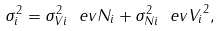<formula> <loc_0><loc_0><loc_500><loc_500>\sigma ^ { 2 } _ { i } = \sigma ^ { 2 } _ { V i } \ e v { N _ { i } } + \sigma ^ { 2 } _ { N i } \ e v { V _ { i } } ^ { 2 } ,</formula> 